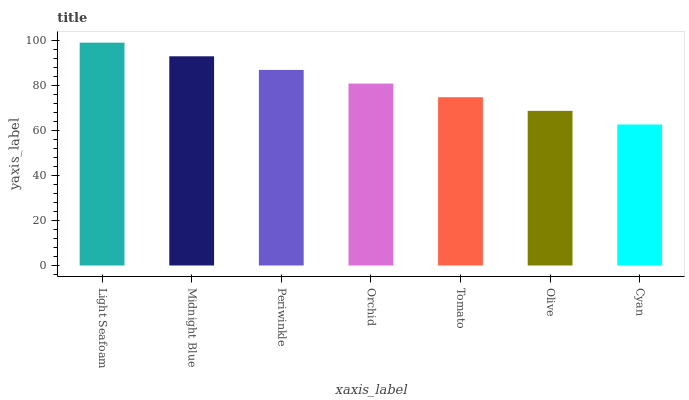Is Cyan the minimum?
Answer yes or no. Yes. Is Light Seafoam the maximum?
Answer yes or no. Yes. Is Midnight Blue the minimum?
Answer yes or no. No. Is Midnight Blue the maximum?
Answer yes or no. No. Is Light Seafoam greater than Midnight Blue?
Answer yes or no. Yes. Is Midnight Blue less than Light Seafoam?
Answer yes or no. Yes. Is Midnight Blue greater than Light Seafoam?
Answer yes or no. No. Is Light Seafoam less than Midnight Blue?
Answer yes or no. No. Is Orchid the high median?
Answer yes or no. Yes. Is Orchid the low median?
Answer yes or no. Yes. Is Light Seafoam the high median?
Answer yes or no. No. Is Midnight Blue the low median?
Answer yes or no. No. 